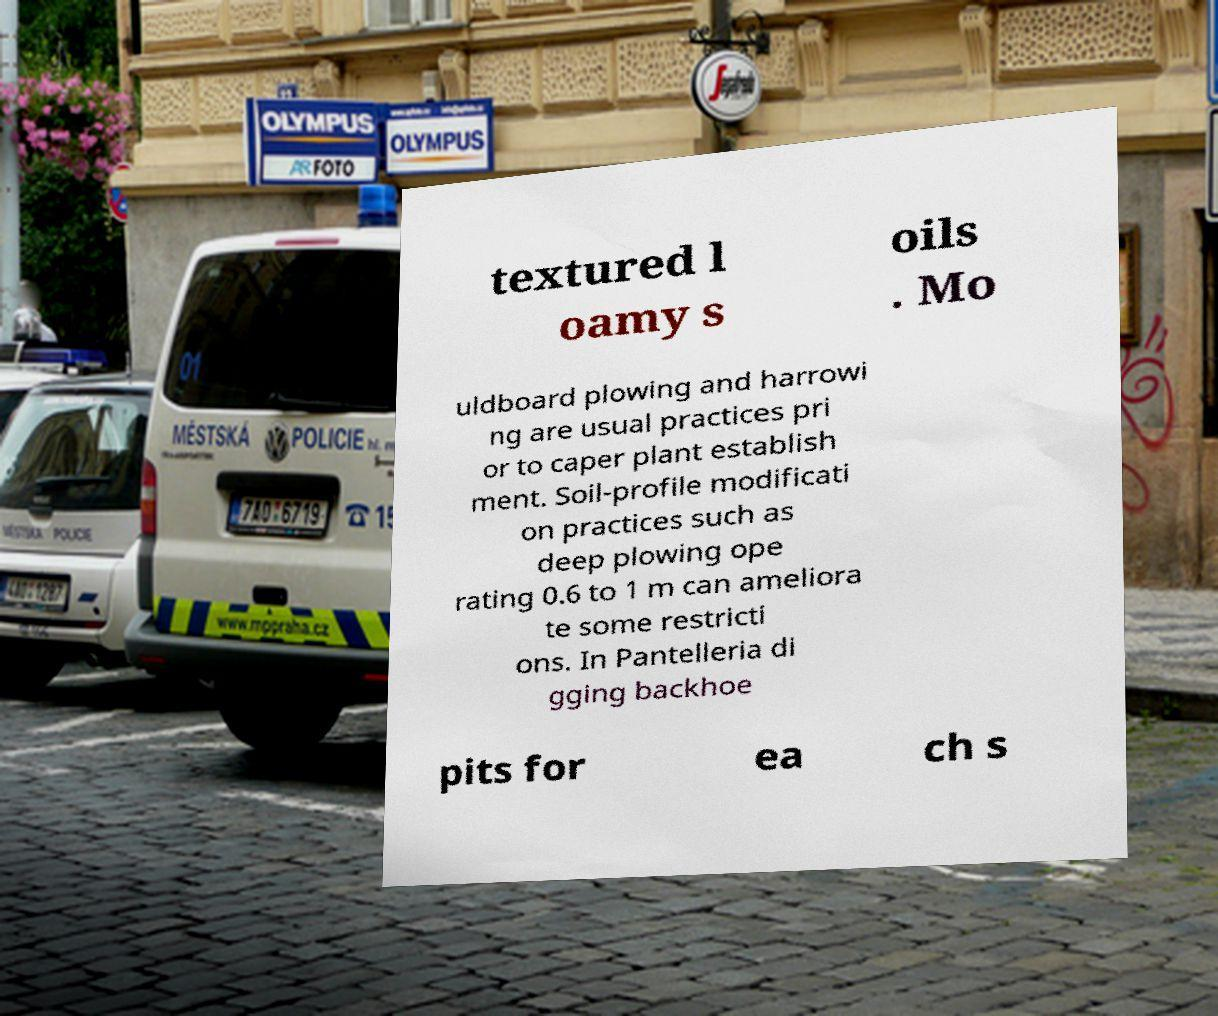Can you accurately transcribe the text from the provided image for me? textured l oamy s oils . Mo uldboard plowing and harrowi ng are usual practices pri or to caper plant establish ment. Soil-profile modificati on practices such as deep plowing ope rating 0.6 to 1 m can ameliora te some restricti ons. In Pantelleria di gging backhoe pits for ea ch s 